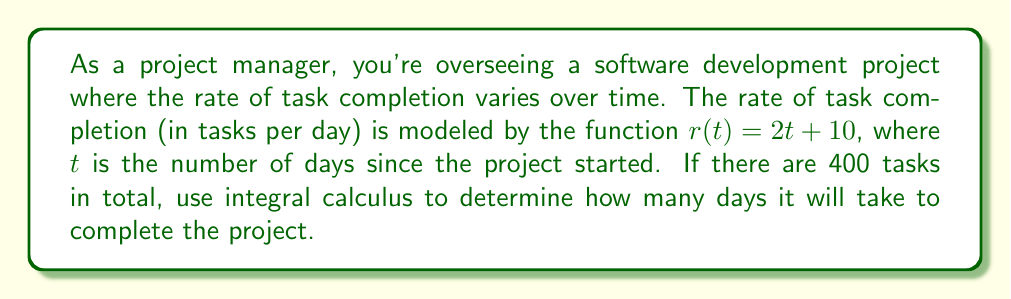Teach me how to tackle this problem. Let's approach this step-by-step:

1) The rate of task completion is given by $r(t) = 2t + 10$ tasks per day.

2) To find the total number of tasks completed up to time $T$, we need to integrate this rate function:

   $$\int_0^T r(t) dt = \int_0^T (2t + 10) dt$$

3) Let's solve this integral:
   
   $$\int_0^T (2t + 10) dt = [t^2 + 10t]_0^T = (T^2 + 10T) - (0^2 + 10(0)) = T^2 + 10T$$

4) This expression represents the total number of tasks completed by time $T$. We want this to equal 400:

   $$T^2 + 10T = 400$$

5) Rearrange the equation:

   $$T^2 + 10T - 400 = 0$$

6) This is a quadratic equation. We can solve it using the quadratic formula:

   $$T = \frac{-b \pm \sqrt{b^2 - 4ac}}{2a}$$

   where $a=1$, $b=10$, and $c=-400$

7) Plugging in these values:

   $$T = \frac{-10 \pm \sqrt{10^2 - 4(1)(-400)}}{2(1)} = \frac{-10 \pm \sqrt{1600 + 100}}{2} = \frac{-10 \pm \sqrt{1700}}{2}$$

8) Simplify:

   $$T = \frac{-10 \pm 41.23}{2}$$

9) This gives us two solutions: $T \approx 15.62$ or $T \approx -25.62$

10) Since time cannot be negative, we take the positive solution.

Therefore, it will take approximately 15.62 days to complete the project.
Answer: 15.62 days 